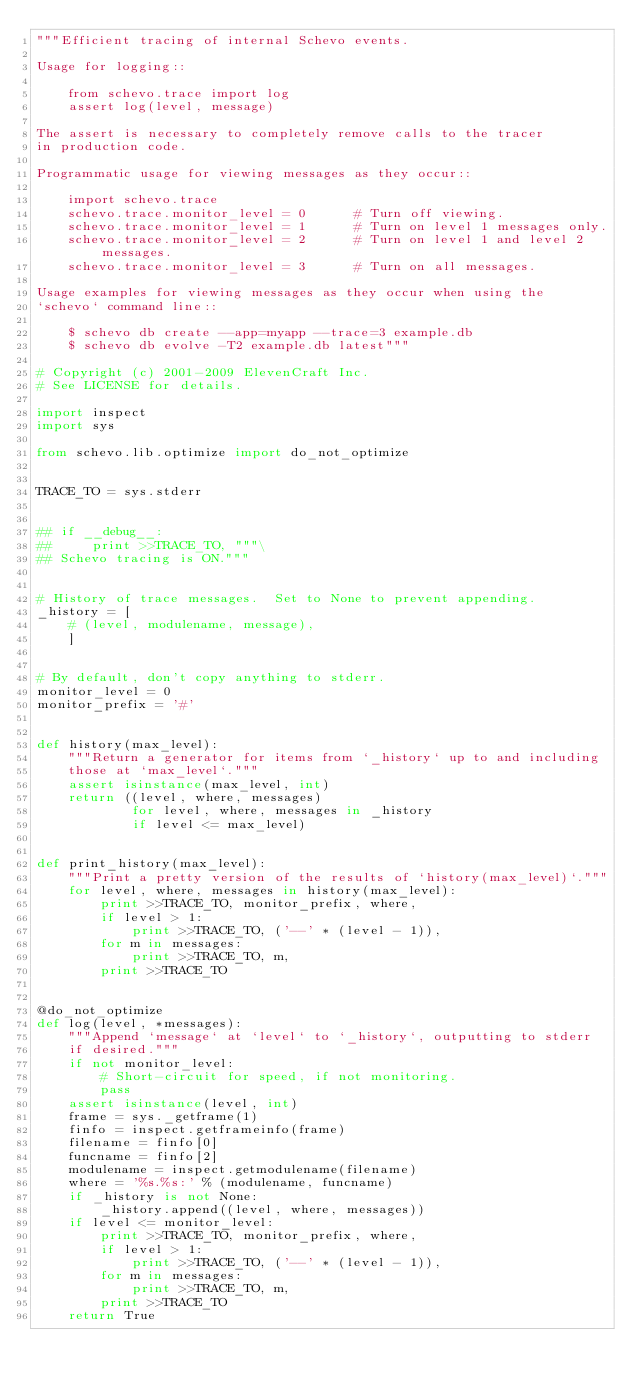Convert code to text. <code><loc_0><loc_0><loc_500><loc_500><_Python_>"""Efficient tracing of internal Schevo events.

Usage for logging::

    from schevo.trace import log
    assert log(level, message)

The assert is necessary to completely remove calls to the tracer
in production code.

Programmatic usage for viewing messages as they occur::

    import schevo.trace
    schevo.trace.monitor_level = 0      # Turn off viewing.
    schevo.trace.monitor_level = 1      # Turn on level 1 messages only.
    schevo.trace.monitor_level = 2      # Turn on level 1 and level 2 messages.
    schevo.trace.monitor_level = 3      # Turn on all messages.

Usage examples for viewing messages as they occur when using the
`schevo` command line::

    $ schevo db create --app=myapp --trace=3 example.db
    $ schevo db evolve -T2 example.db latest"""

# Copyright (c) 2001-2009 ElevenCraft Inc.
# See LICENSE for details.

import inspect
import sys

from schevo.lib.optimize import do_not_optimize


TRACE_TO = sys.stderr


## if __debug__:
##     print >>TRACE_TO, """\
## Schevo tracing is ON."""


# History of trace messages.  Set to None to prevent appending.
_history = [
    # (level, modulename, message),
    ]


# By default, don't copy anything to stderr.
monitor_level = 0
monitor_prefix = '#'


def history(max_level):
    """Return a generator for items from `_history` up to and including
    those at `max_level`."""
    assert isinstance(max_level, int)
    return ((level, where, messages)
            for level, where, messages in _history
            if level <= max_level)


def print_history(max_level):
    """Print a pretty version of the results of `history(max_level)`."""
    for level, where, messages in history(max_level):
        print >>TRACE_TO, monitor_prefix, where,
        if level > 1:
            print >>TRACE_TO, ('--' * (level - 1)),
        for m in messages:
            print >>TRACE_TO, m,
        print >>TRACE_TO


@do_not_optimize
def log(level, *messages):
    """Append `message` at `level` to `_history`, outputting to stderr
    if desired."""
    if not monitor_level:
        # Short-circuit for speed, if not monitoring.
        pass
    assert isinstance(level, int)
    frame = sys._getframe(1)
    finfo = inspect.getframeinfo(frame)
    filename = finfo[0]
    funcname = finfo[2]
    modulename = inspect.getmodulename(filename)
    where = '%s.%s:' % (modulename, funcname)
    if _history is not None:
        _history.append((level, where, messages))
    if level <= monitor_level:
        print >>TRACE_TO, monitor_prefix, where,
        if level > 1:
            print >>TRACE_TO, ('--' * (level - 1)),
        for m in messages:
            print >>TRACE_TO, m,
        print >>TRACE_TO
    return True
</code> 